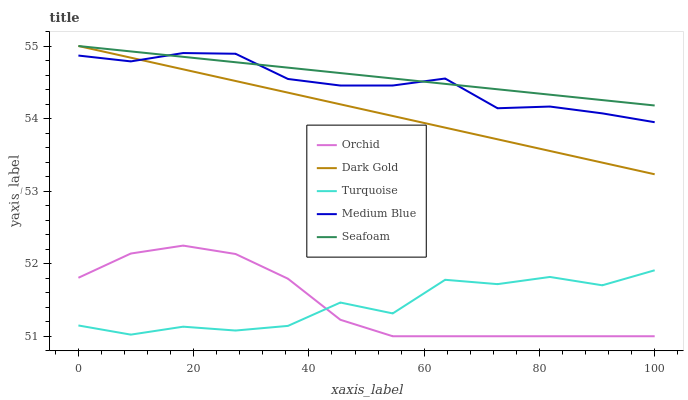Does Turquoise have the minimum area under the curve?
Answer yes or no. Yes. Does Seafoam have the maximum area under the curve?
Answer yes or no. Yes. Does Dark Gold have the minimum area under the curve?
Answer yes or no. No. Does Dark Gold have the maximum area under the curve?
Answer yes or no. No. Is Dark Gold the smoothest?
Answer yes or no. Yes. Is Turquoise the roughest?
Answer yes or no. Yes. Is Medium Blue the smoothest?
Answer yes or no. No. Is Medium Blue the roughest?
Answer yes or no. No. Does Orchid have the lowest value?
Answer yes or no. Yes. Does Dark Gold have the lowest value?
Answer yes or no. No. Does Seafoam have the highest value?
Answer yes or no. Yes. Does Medium Blue have the highest value?
Answer yes or no. No. Is Orchid less than Dark Gold?
Answer yes or no. Yes. Is Medium Blue greater than Orchid?
Answer yes or no. Yes. Does Seafoam intersect Dark Gold?
Answer yes or no. Yes. Is Seafoam less than Dark Gold?
Answer yes or no. No. Is Seafoam greater than Dark Gold?
Answer yes or no. No. Does Orchid intersect Dark Gold?
Answer yes or no. No. 